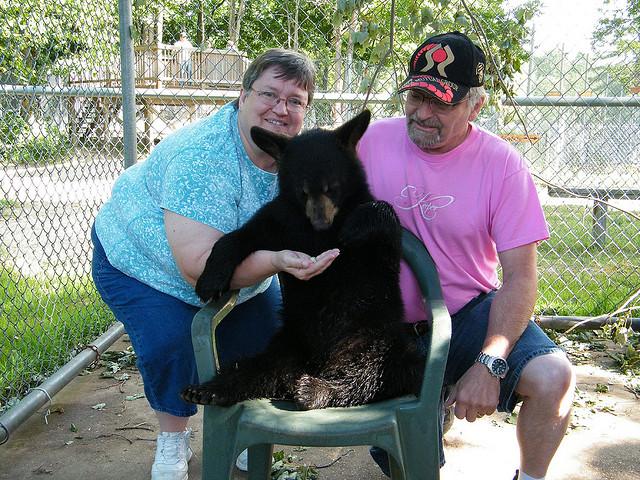What color is the guys shirt?
Short answer required. Pink. What is the bear sitting in?
Keep it brief. Chair. Can this bear survive in the wild on its own without its mother?
Quick response, please. No. 